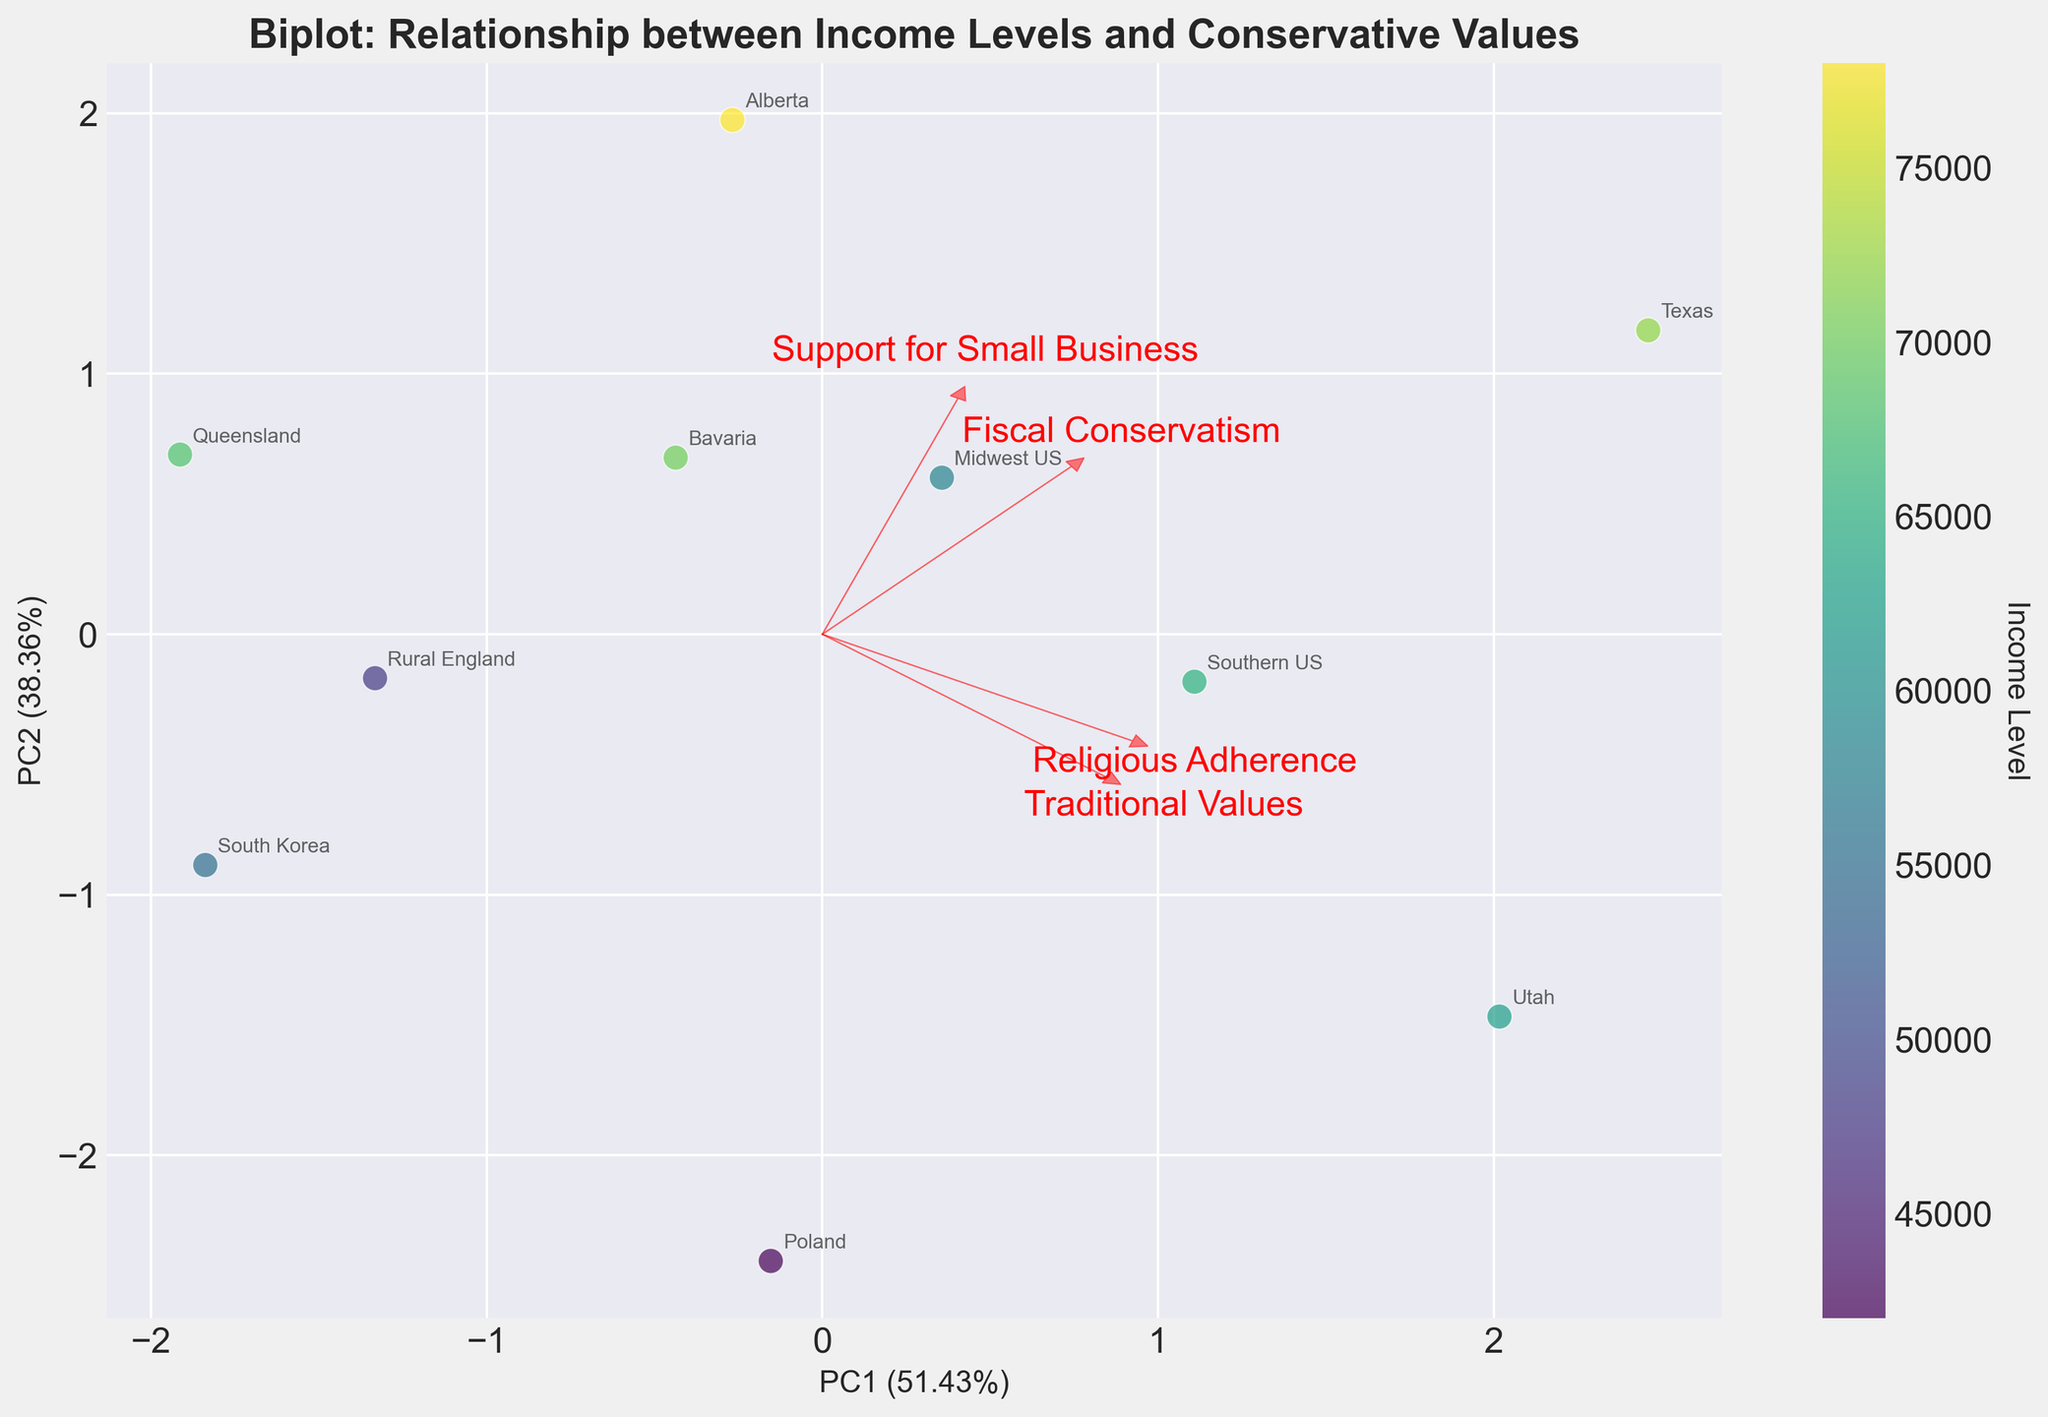What does the title of the biplot indicate? The title of the biplot is: "Biplot: Relationship between Income Levels and Conservative Values". This indicates that the biplot explores how different income levels and conservative values are related in various geographic regions.
Answer: The relationship between income levels and conservative values How are the axes labeled and what do they represent? The x-axis is labeled "PC1" which explains the largest variation in the data, and the y-axis is labeled "PC2" which explains the second largest variation. Both axes show how much variance they explain in percentage terms.
Answer: PC1 and PC2 Which region has the highest income level and where is it located on the plot? Texas has the highest income level of $72,000. It can be located by finding its label on the plot.
Answer: Texas Which features have the longest arrows and what does this indicate? Traditional Values and Religious Adherence have the longest arrows. This indicates that these features contribute the most to the variance explained by the principal components.
Answer: Traditional Values and Religious Adherence Is there any region that stands out as an outlier in the plot? By examining the plot, Alberta appears as an outlier as it seems to be positioned farther from the other regions on the PCA axes.
Answer: Alberta How does Religious Adherence vary with PC1? By observing the direction of the arrow for Religious Adherence, it is closely aligned with PC1 suggesting that higher values of Religious Adherence are positively associated with PC1.
Answer: Positively associated Which regions cluster closely together on the plot? Midwest US and Rural England cluster closely together on the plot, indicating they have similar conservative values and income levels.
Answer: Midwest US and Rural England What can be inferred about the relationship between Fiscal Conservatism and PC2? The arrow for Fiscal Conservatism is aligned closer to the vertical PC2 axis. This implies that regions with higher fiscal conservatism are more positively associated with PC2.
Answer: Positively associated with PC2 How does Support for Small Business relate to Traditional Values based on their arrows? The arrows for Support for Small Business and Traditional Values point in approximately the same direction, indicating a positive relationship between these two variables.
Answer: Positive relationship What's the range of income levels represented by the regions on the color scale? The income levels range from $42,000 (Poland) to $72,000 (Texas), as indicated by the color gradient on the plot.
Answer: $42,000 to $72,000 